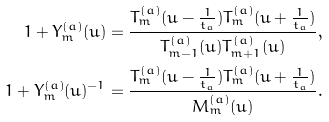<formula> <loc_0><loc_0><loc_500><loc_500>1 + Y _ { m } ^ { ( a ) } ( u ) & = \frac { T _ { m } ^ { ( a ) } ( u - \frac { 1 } { t _ { a } } ) T _ { m } ^ { ( a ) } ( u + \frac { 1 } { t _ { a } } ) } { T _ { m - 1 } ^ { ( a ) } ( u ) T _ { m + 1 } ^ { ( a ) } ( u ) } , \\ 1 + Y _ { m } ^ { ( a ) } ( u ) ^ { - 1 } & = \frac { T _ { m } ^ { ( a ) } ( u - \frac { 1 } { t _ { a } } ) T _ { m } ^ { ( a ) } ( u + \frac { 1 } { t _ { a } } ) } { M _ { m } ^ { ( a ) } ( u ) } .</formula> 